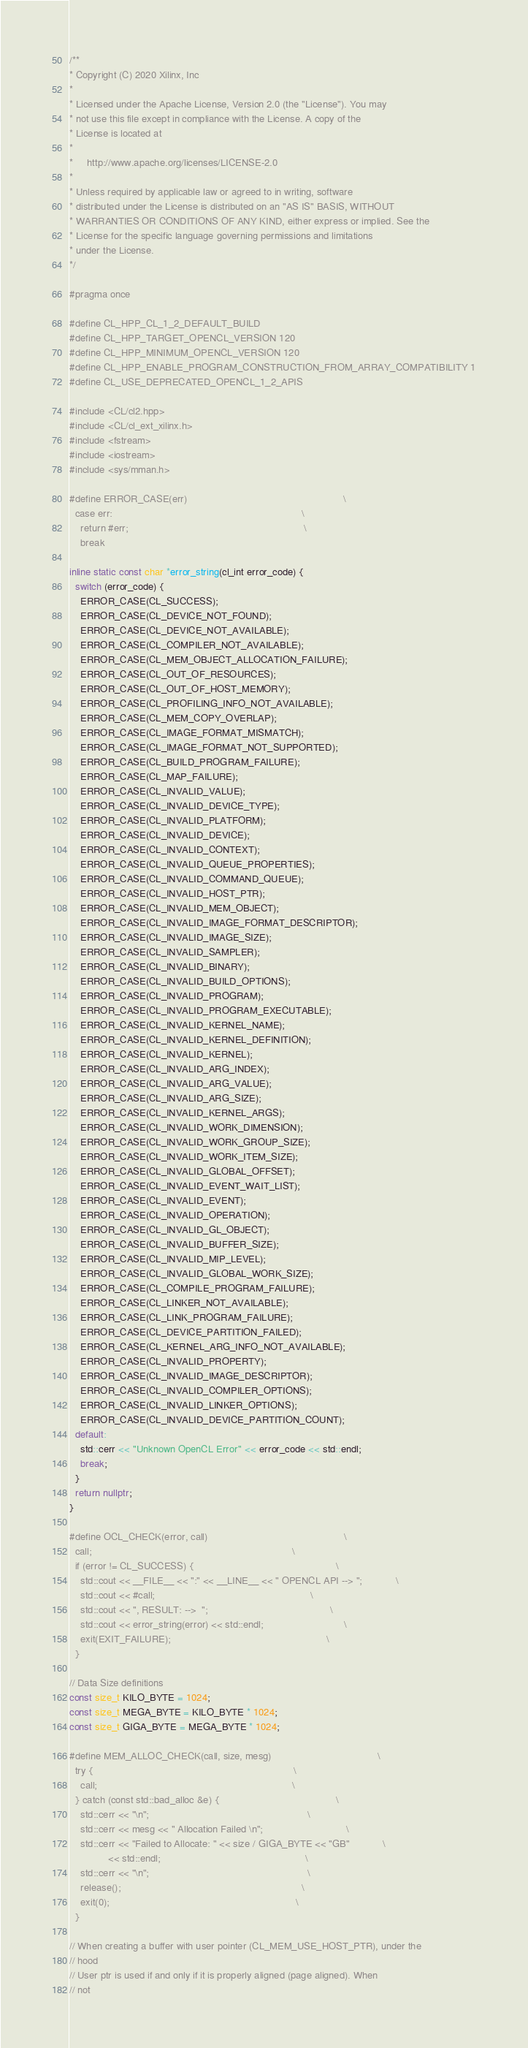Convert code to text. <code><loc_0><loc_0><loc_500><loc_500><_C++_>/**
* Copyright (C) 2020 Xilinx, Inc
*
* Licensed under the Apache License, Version 2.0 (the "License"). You may
* not use this file except in compliance with the License. A copy of the
* License is located at
*
*     http://www.apache.org/licenses/LICENSE-2.0
*
* Unless required by applicable law or agreed to in writing, software
* distributed under the License is distributed on an "AS IS" BASIS, WITHOUT
* WARRANTIES OR CONDITIONS OF ANY KIND, either express or implied. See the
* License for the specific language governing permissions and limitations
* under the License.
*/

#pragma once

#define CL_HPP_CL_1_2_DEFAULT_BUILD
#define CL_HPP_TARGET_OPENCL_VERSION 120
#define CL_HPP_MINIMUM_OPENCL_VERSION 120
#define CL_HPP_ENABLE_PROGRAM_CONSTRUCTION_FROM_ARRAY_COMPATIBILITY 1
#define CL_USE_DEPRECATED_OPENCL_1_2_APIS

#include <CL/cl2.hpp>
#include <CL/cl_ext_xilinx.h>
#include <fstream>
#include <iostream>
#include <sys/mman.h>

#define ERROR_CASE(err)                                                        \
  case err:                                                                    \
    return #err;                                                               \
    break

inline static const char *error_string(cl_int error_code) {
  switch (error_code) {
    ERROR_CASE(CL_SUCCESS);
    ERROR_CASE(CL_DEVICE_NOT_FOUND);
    ERROR_CASE(CL_DEVICE_NOT_AVAILABLE);
    ERROR_CASE(CL_COMPILER_NOT_AVAILABLE);
    ERROR_CASE(CL_MEM_OBJECT_ALLOCATION_FAILURE);
    ERROR_CASE(CL_OUT_OF_RESOURCES);
    ERROR_CASE(CL_OUT_OF_HOST_MEMORY);
    ERROR_CASE(CL_PROFILING_INFO_NOT_AVAILABLE);
    ERROR_CASE(CL_MEM_COPY_OVERLAP);
    ERROR_CASE(CL_IMAGE_FORMAT_MISMATCH);
    ERROR_CASE(CL_IMAGE_FORMAT_NOT_SUPPORTED);
    ERROR_CASE(CL_BUILD_PROGRAM_FAILURE);
    ERROR_CASE(CL_MAP_FAILURE);
    ERROR_CASE(CL_INVALID_VALUE);
    ERROR_CASE(CL_INVALID_DEVICE_TYPE);
    ERROR_CASE(CL_INVALID_PLATFORM);
    ERROR_CASE(CL_INVALID_DEVICE);
    ERROR_CASE(CL_INVALID_CONTEXT);
    ERROR_CASE(CL_INVALID_QUEUE_PROPERTIES);
    ERROR_CASE(CL_INVALID_COMMAND_QUEUE);
    ERROR_CASE(CL_INVALID_HOST_PTR);
    ERROR_CASE(CL_INVALID_MEM_OBJECT);
    ERROR_CASE(CL_INVALID_IMAGE_FORMAT_DESCRIPTOR);
    ERROR_CASE(CL_INVALID_IMAGE_SIZE);
    ERROR_CASE(CL_INVALID_SAMPLER);
    ERROR_CASE(CL_INVALID_BINARY);
    ERROR_CASE(CL_INVALID_BUILD_OPTIONS);
    ERROR_CASE(CL_INVALID_PROGRAM);
    ERROR_CASE(CL_INVALID_PROGRAM_EXECUTABLE);
    ERROR_CASE(CL_INVALID_KERNEL_NAME);
    ERROR_CASE(CL_INVALID_KERNEL_DEFINITION);
    ERROR_CASE(CL_INVALID_KERNEL);
    ERROR_CASE(CL_INVALID_ARG_INDEX);
    ERROR_CASE(CL_INVALID_ARG_VALUE);
    ERROR_CASE(CL_INVALID_ARG_SIZE);
    ERROR_CASE(CL_INVALID_KERNEL_ARGS);
    ERROR_CASE(CL_INVALID_WORK_DIMENSION);
    ERROR_CASE(CL_INVALID_WORK_GROUP_SIZE);
    ERROR_CASE(CL_INVALID_WORK_ITEM_SIZE);
    ERROR_CASE(CL_INVALID_GLOBAL_OFFSET);
    ERROR_CASE(CL_INVALID_EVENT_WAIT_LIST);
    ERROR_CASE(CL_INVALID_EVENT);
    ERROR_CASE(CL_INVALID_OPERATION);
    ERROR_CASE(CL_INVALID_GL_OBJECT);
    ERROR_CASE(CL_INVALID_BUFFER_SIZE);
    ERROR_CASE(CL_INVALID_MIP_LEVEL);
    ERROR_CASE(CL_INVALID_GLOBAL_WORK_SIZE);
    ERROR_CASE(CL_COMPILE_PROGRAM_FAILURE);
    ERROR_CASE(CL_LINKER_NOT_AVAILABLE);
    ERROR_CASE(CL_LINK_PROGRAM_FAILURE);
    ERROR_CASE(CL_DEVICE_PARTITION_FAILED);
    ERROR_CASE(CL_KERNEL_ARG_INFO_NOT_AVAILABLE);
    ERROR_CASE(CL_INVALID_PROPERTY);
    ERROR_CASE(CL_INVALID_IMAGE_DESCRIPTOR);
    ERROR_CASE(CL_INVALID_COMPILER_OPTIONS);
    ERROR_CASE(CL_INVALID_LINKER_OPTIONS);
    ERROR_CASE(CL_INVALID_DEVICE_PARTITION_COUNT);
  default:
    std::cerr << "Unknown OpenCL Error" << error_code << std::endl;
    break;
  }
  return nullptr;
}

#define OCL_CHECK(error, call)                                                 \
  call;                                                                        \
  if (error != CL_SUCCESS) {                                                   \
    std::cout << __FILE__ << ":" << __LINE__ << " OPENCL API --> ";            \
    std::cout << #call;                                                        \
    std::cout << ", RESULT: -->  ";                                            \
    std::cout << error_string(error) << std::endl;                             \
    exit(EXIT_FAILURE);                                                        \
  }

// Data Size definitions
const size_t KILO_BYTE = 1024;
const size_t MEGA_BYTE = KILO_BYTE * 1024;
const size_t GIGA_BYTE = MEGA_BYTE * 1024;

#define MEM_ALLOC_CHECK(call, size, mesg)                                      \
  try {                                                                        \
    call;                                                                      \
  } catch (const std::bad_alloc &e) {                                          \
    std::cerr << "\n";                                                         \
    std::cerr << mesg << " Allocation Failed \n";                              \
    std::cerr << "Failed to Allocate: " << size / GIGA_BYTE << "GB"            \
              << std::endl;                                                    \
    std::cerr << "\n";                                                         \
    release();                                                                 \
    exit(0);                                                                   \
  }

// When creating a buffer with user pointer (CL_MEM_USE_HOST_PTR), under the
// hood
// User ptr is used if and only if it is properly aligned (page aligned). When
// not</code> 